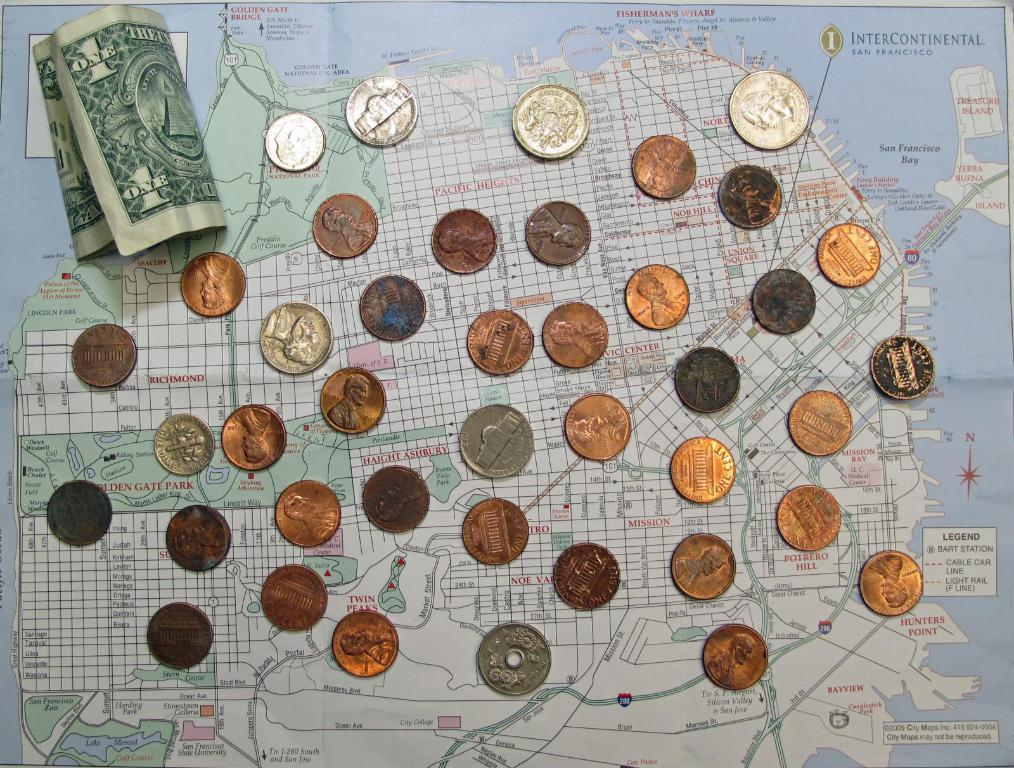<image>
Describe the image concisely. A collection of coins on the table with one paper 1 dollar. 